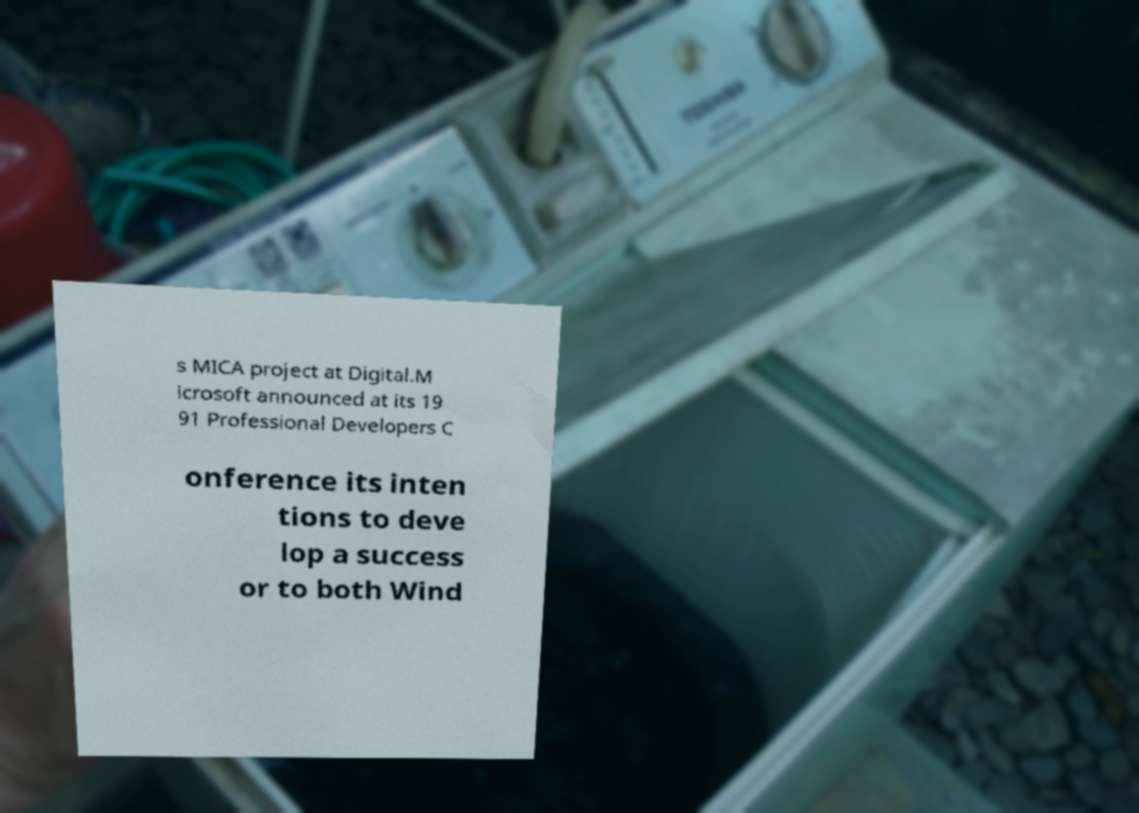Please read and relay the text visible in this image. What does it say? s MICA project at Digital.M icrosoft announced at its 19 91 Professional Developers C onference its inten tions to deve lop a success or to both Wind 